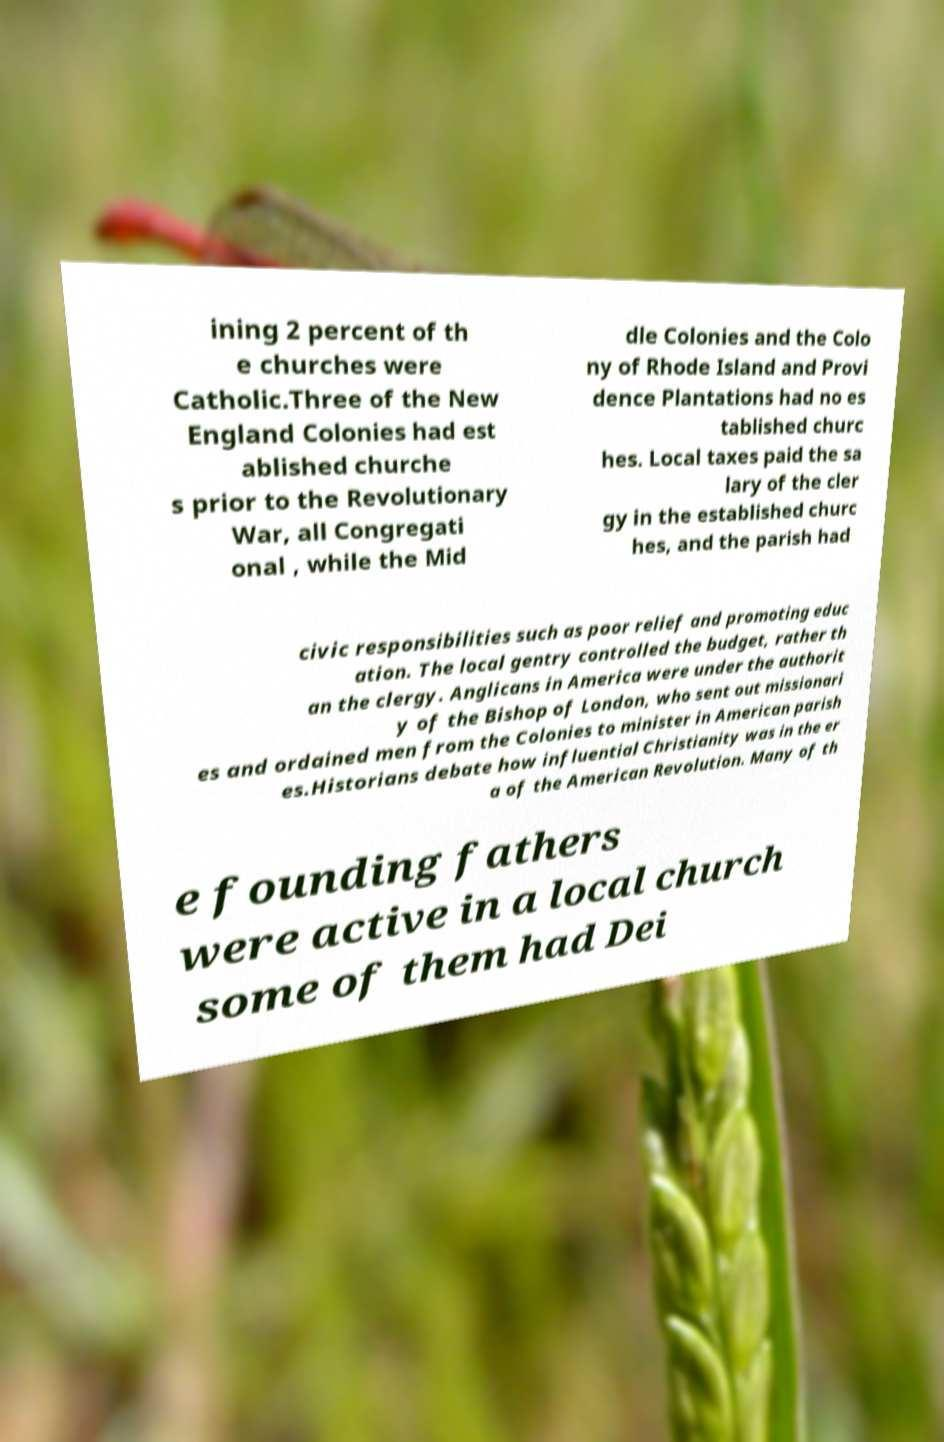Please read and relay the text visible in this image. What does it say? ining 2 percent of th e churches were Catholic.Three of the New England Colonies had est ablished churche s prior to the Revolutionary War, all Congregati onal , while the Mid dle Colonies and the Colo ny of Rhode Island and Provi dence Plantations had no es tablished churc hes. Local taxes paid the sa lary of the cler gy in the established churc hes, and the parish had civic responsibilities such as poor relief and promoting educ ation. The local gentry controlled the budget, rather th an the clergy. Anglicans in America were under the authorit y of the Bishop of London, who sent out missionari es and ordained men from the Colonies to minister in American parish es.Historians debate how influential Christianity was in the er a of the American Revolution. Many of th e founding fathers were active in a local church some of them had Dei 